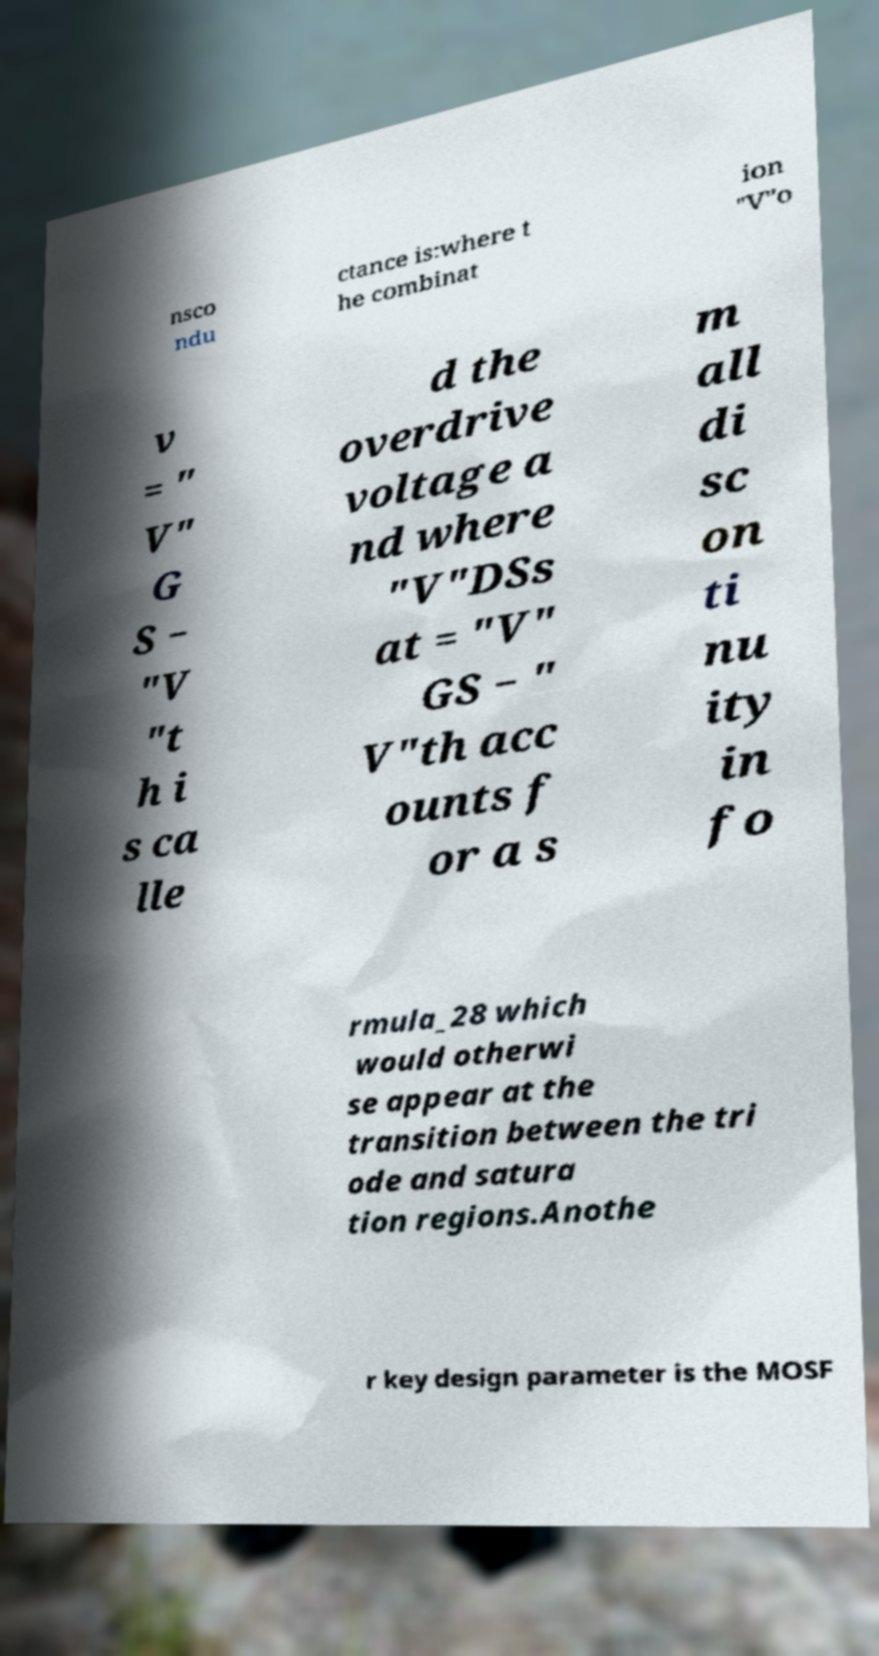Please identify and transcribe the text found in this image. nsco ndu ctance is:where t he combinat ion "V"o v = " V" G S − "V "t h i s ca lle d the overdrive voltage a nd where "V"DSs at = "V" GS − " V"th acc ounts f or a s m all di sc on ti nu ity in fo rmula_28 which would otherwi se appear at the transition between the tri ode and satura tion regions.Anothe r key design parameter is the MOSF 